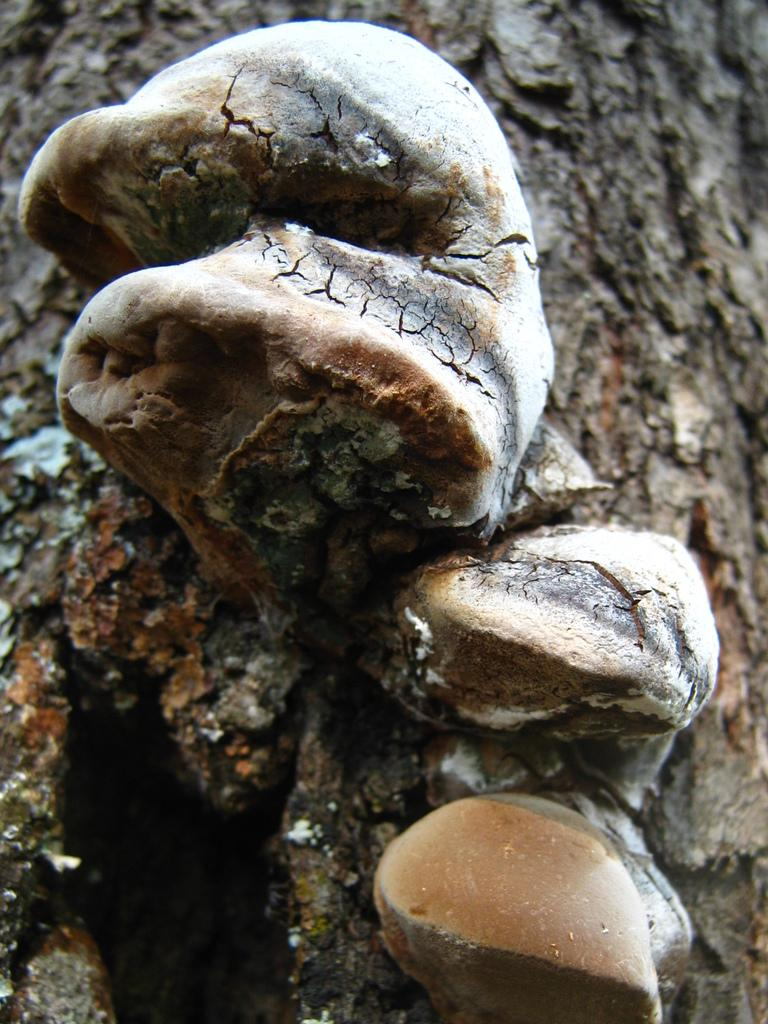What type of organism can be seen on the branch in the image? There is fungus on a branch in the image. What type of houses are depicted in the image? There are no houses present in the image; it features fungus on a branch. What organization or company is responsible for the fungus in the image? The image does not provide information about any organization or company being responsible for the fungus. 